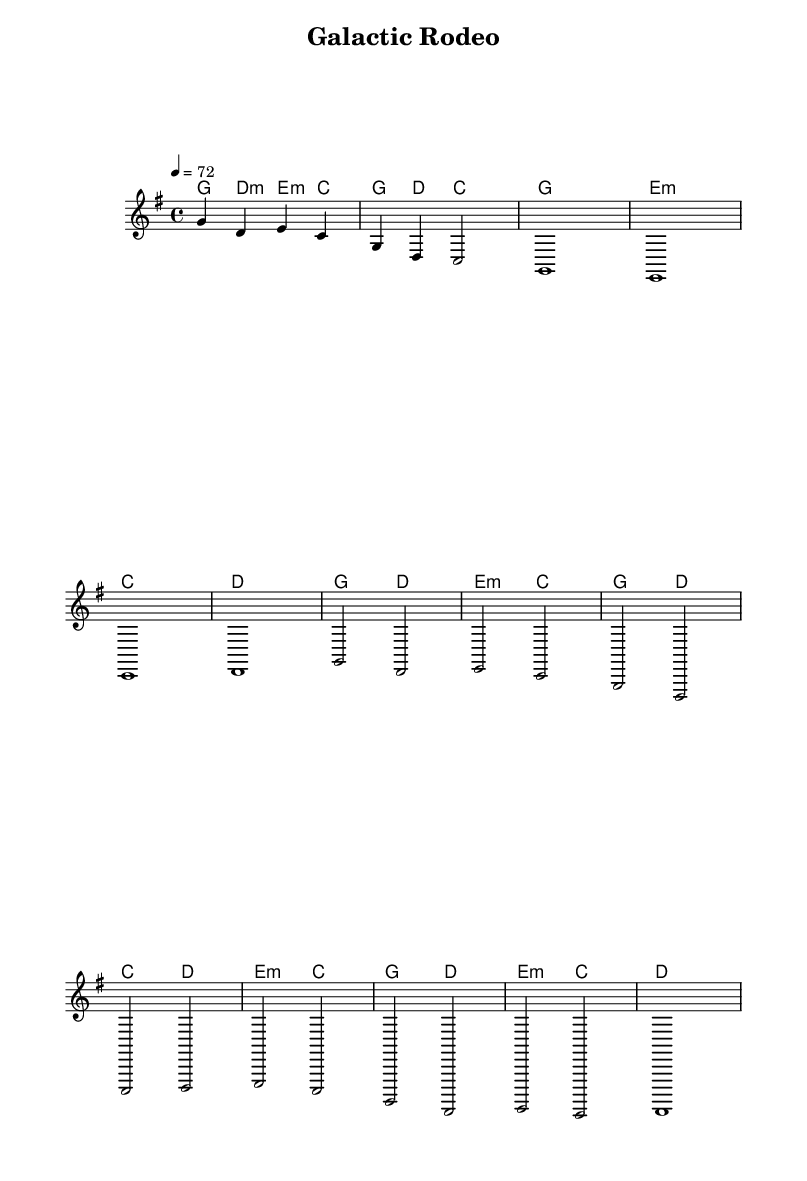What is the key signature of this music? The key signature is G major, which has one sharp (F#) shown in the key signature at the beginning of the staff.
Answer: G major What is the time signature of this music? The time signature is 4/4, which means there are four beats in each measure and the quarter note gets one beat, indicated at the beginning of the piece.
Answer: 4/4 What is the tempo marking of this piece? The tempo is marked as quarter note equals 72, indicating the speed at which the piece should be played, found near the beginning of the score.
Answer: 72 How many measures are in the chorus section? The chorus section contains four measures, which can be counted by examining the measures labeled with the melody and harmonies.
Answer: 4 What type of musical form is used in this piece? The piece features a verse-chorus structure, typical for songs, which can be identified by the distinct sections indicated in the melody notation.
Answer: Verse-Chorus What chords are played in the bridge section? The bridge section consists of the chords E minor, C, G, D, and E minor again, which can be detected by looking at the harmony part of the bridge section labeled in the score.
Answer: E minor, C, G, D, E minor What is the predominant style of this composition? The predominant style is country ballad, as suggested by the melodic simplicity, narrative structure, and emotional thematic elements which are characteristic of country music.
Answer: Country ballad 